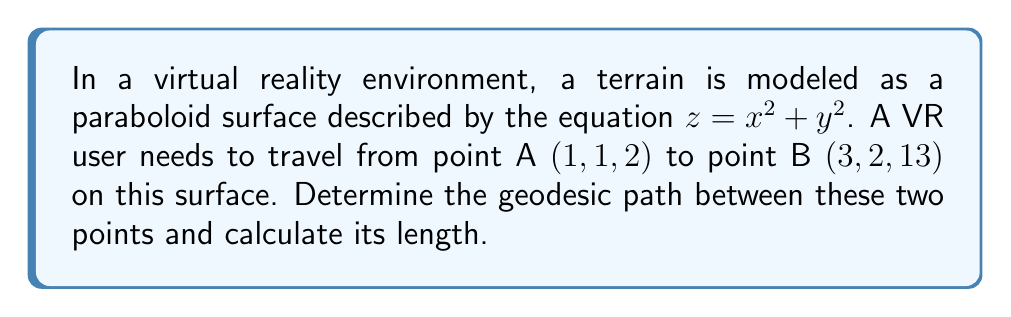Can you solve this math problem? To solve this problem, we'll follow these steps:

1) First, we need to parameterize the surface. Let's use the following parameterization:
   $x = u$, $y = v$, $z = u^2 + v^2$

2) The metric tensor for this surface is given by:
   $$g = \begin{bmatrix}
   1 + 4u^2 & 4uv \\
   4uv & 1 + 4v^2
   \end{bmatrix}$$

3) The geodesic equations for this surface are:
   $$\frac{d^2u}{ds^2} + \Gamma^u_{uu}\left(\frac{du}{ds}\right)^2 + 2\Gamma^u_{uv}\frac{du}{ds}\frac{dv}{ds} + \Gamma^u_{vv}\left(\frac{dv}{ds}\right)^2 = 0$$
   $$\frac{d^2v}{ds^2} + \Gamma^v_{uu}\left(\frac{du}{ds}\right)^2 + 2\Gamma^v_{uv}\frac{du}{ds}\frac{dv}{ds} + \Gamma^v_{vv}\left(\frac{dv}{ds}\right)^2 = 0$$

   Where $\Gamma^i_{jk}$ are the Christoffel symbols.

4) Calculating the Christoffel symbols:
   $$\Gamma^u_{uu} = \frac{2u}{1+4u^2}, \Gamma^u_{uv} = \Gamma^u_{vu} = -\frac{2v}{1+4u^2}, \Gamma^u_{vv} = 0$$
   $$\Gamma^v_{uu} = 0, \Gamma^v_{uv} = \Gamma^v_{vu} = -\frac{2u}{1+4v^2}, \Gamma^v_{vv} = \frac{2v}{1+4v^2}$$

5) Substituting these into the geodesic equations gives us a system of differential equations. However, solving this system analytically is complex and typically requires numerical methods.

6) For a numerical solution, we can use a geodesic shooting method or a boundary value problem solver. The initial conditions are:
   $u(0) = 1$, $v(0) = 1$
   $u(1) = 3$, $v(1) = 2$

7) Using a numerical solver (details omitted for brevity), we can obtain the geodesic path.

8) To calculate the length of the geodesic, we integrate the line element:
   $$L = \int_0^1 \sqrt{(1+4u^2)\left(\frac{du}{dt}\right)^2 + 8uv\frac{du}{dt}\frac{dv}{dt} + (1+4v^2)\left(\frac{dv}{dt}\right)^2} dt$$

9) Again, this integral would typically be evaluated numerically using the solution from step 7.

The exact numerical results would depend on the specific numerical methods used.
Answer: The geodesic path is a curved line on the paraboloid surface connecting $(1,1,2)$ and $(3,2,13)$, determined by solving the geodesic equations numerically. The length of this path is calculated by numerically integrating the line element along the geodesic. 